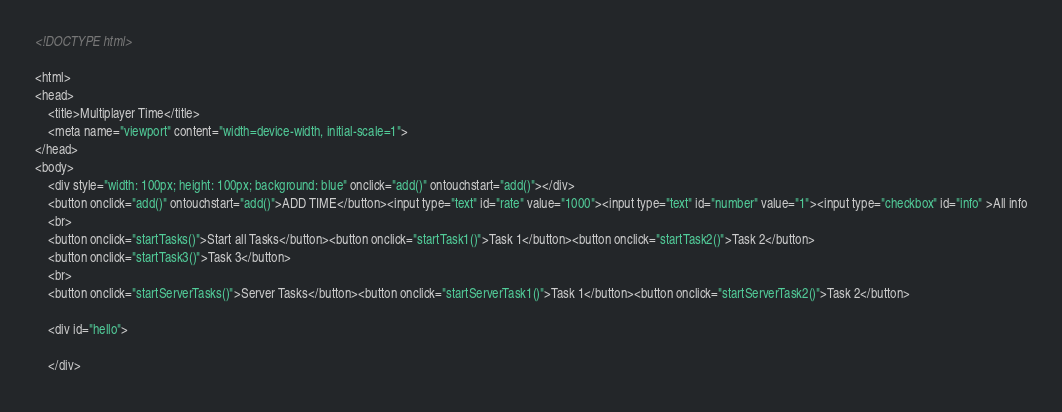<code> <loc_0><loc_0><loc_500><loc_500><_HTML_><!DOCTYPE html>

<html>
<head>
	<title>Multiplayer Time</title>
	<meta name="viewport" content="width=device-width, initial-scale=1">
</head>
<body>
	<div style="width: 100px; height: 100px; background: blue" onclick="add()" ontouchstart="add()"></div>
	<button onclick="add()" ontouchstart="add()">ADD TIME</button><input type="text" id="rate" value="1000"><input type="text" id="number" value="1"><input type="checkbox" id="info" >All info
	<br>
	<button onclick="startTasks()">Start all Tasks</button><button onclick="startTask1()">Task 1</button><button onclick="startTask2()">Task 2</button>
	<button onclick="startTask3()">Task 3</button>
	<br>
	<button onclick="startServerTasks()">Server Tasks</button><button onclick="startServerTask1()">Task 1</button><button onclick="startServerTask2()">Task 2</button>

	<div id="hello">

	</div>

</code> 